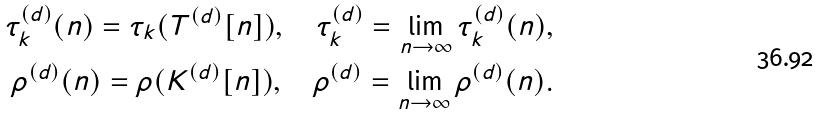<formula> <loc_0><loc_0><loc_500><loc_500>\tau ^ { ( d ) } _ { k } ( n ) = \tau _ { k } ( T ^ { ( d ) } [ n ] ) , \quad \tau ^ { ( d ) } _ { k } = \lim _ { n \rightarrow \infty } \tau ^ { ( d ) } _ { k } ( n ) , \\ \rho ^ { ( d ) } ( n ) = \rho ( K ^ { ( d ) } [ n ] ) , \quad \rho ^ { ( d ) } = \lim _ { n \rightarrow \infty } \rho ^ { ( d ) } ( n ) .</formula> 